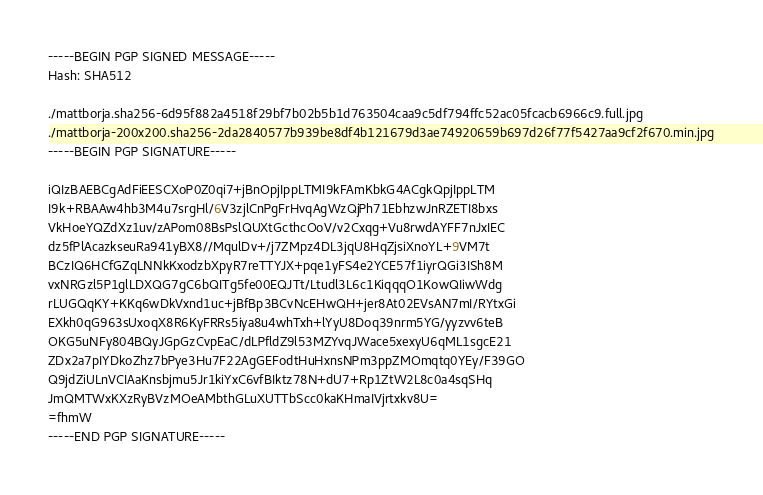<code> <loc_0><loc_0><loc_500><loc_500><_SML_>-----BEGIN PGP SIGNED MESSAGE-----
Hash: SHA512

./mattborja.sha256-6d95f882a4518f29bf7b02b5b1d763504caa9c5df794ffc52ac05fcacb6966c9.full.jpg
./mattborja-200x200.sha256-2da2840577b939be8df4b121679d3ae74920659b697d26f77f5427aa9cf2f670.min.jpg
-----BEGIN PGP SIGNATURE-----

iQIzBAEBCgAdFiEESCXoP0Z0qi7+jBnOpjIppLTMI9kFAmKbkG4ACgkQpjIppLTM
I9k+RBAAw4hb3M4u7srgHl/6V3zjlCnPgFrHvqAgWzQjPh71EbhzwJnRZETI8bxs
VkHoeYQZdXz1uv/zAPom08BsPslQUXtGcthcOoV/v2Cxqg+Vu8rwdAYFF7nJxIEC
dz5fPlAcazkseuRa941yBX8//MqulDv+/j7ZMpz4DL3jqU8HqZjsiXnoYL+9VM7t
BCzIQ6HCfGZqLNNkKxodzbXpyR7reTTYJX+pqe1yFS4e2YCE57f1iyrQGi3ISh8M
vxNRGzl5P1glLDXQG7gC6bQITg5fe00EQJTt/Ltudl3L6c1KiqqqO1KowQIiwWdg
rLUGQqKY+KKq6wDkVxnd1uc+jBfBp3BCvNcEHwQH+jer8At02EVsAN7mI/RYtxGi
EXkh0qG963sUxoqX8R6KyFRRs5iya8u4whTxh+lYyU8Doq39nrm5YG/yyzvv6teB
OKG5uNFy804BQyJGpGzCvpEaC/dLPfldZ9l53MZYvqJWace5xexyU6qML1sgcE21
ZDx2a7pIYDkoZhz7bPye3Hu7F22AgGEFodtHuHxnsNPm3ppZMOmqtq0YEy/F39GO
Q9jdZiULnVCIAaKnsbjmu5Jr1kiYxC6vfBIktz78N+dU7+Rp1ZtW2L8c0a4sqSHq
JmQMTWxKXzRyBVzMOeAMbthGLuXUTTbScc0kaKHmaIVjrtxkv8U=
=fhmW
-----END PGP SIGNATURE-----
</code> 